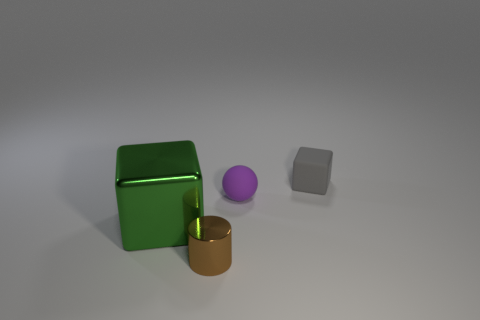Is the green shiny thing the same shape as the purple matte thing?
Make the answer very short. No. What is the color of the tiny cylinder that is the same material as the big green thing?
Your response must be concise. Brown. How many things are either metallic objects to the left of the tiny metal object or large brown shiny objects?
Give a very brief answer. 1. There is a cube that is on the left side of the tiny ball; what size is it?
Ensure brevity in your answer.  Large. There is a rubber cube; is it the same size as the cube in front of the small purple rubber sphere?
Offer a terse response. No. The block to the right of the cube on the left side of the small matte block is what color?
Your response must be concise. Gray. How many other objects are the same color as the small metallic cylinder?
Offer a terse response. 0. What is the size of the green object?
Your response must be concise. Large. Is the number of big green cubes that are to the right of the purple matte object greater than the number of big cubes that are to the right of the metallic cube?
Your answer should be very brief. No. How many cubes are on the left side of the cube that is behind the green metallic object?
Make the answer very short. 1. 